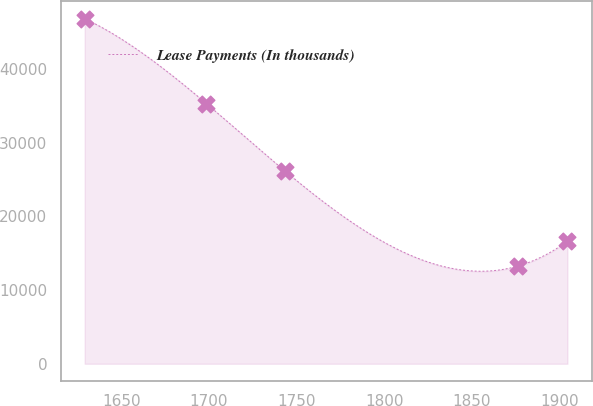Convert chart to OTSL. <chart><loc_0><loc_0><loc_500><loc_500><line_chart><ecel><fcel>Lease Payments (In thousands)<nl><fcel>1629.21<fcel>46833.2<nl><fcel>1698.62<fcel>35304.7<nl><fcel>1743.46<fcel>26152.5<nl><fcel>1876.53<fcel>13278.5<nl><fcel>1904.49<fcel>16634<nl></chart> 